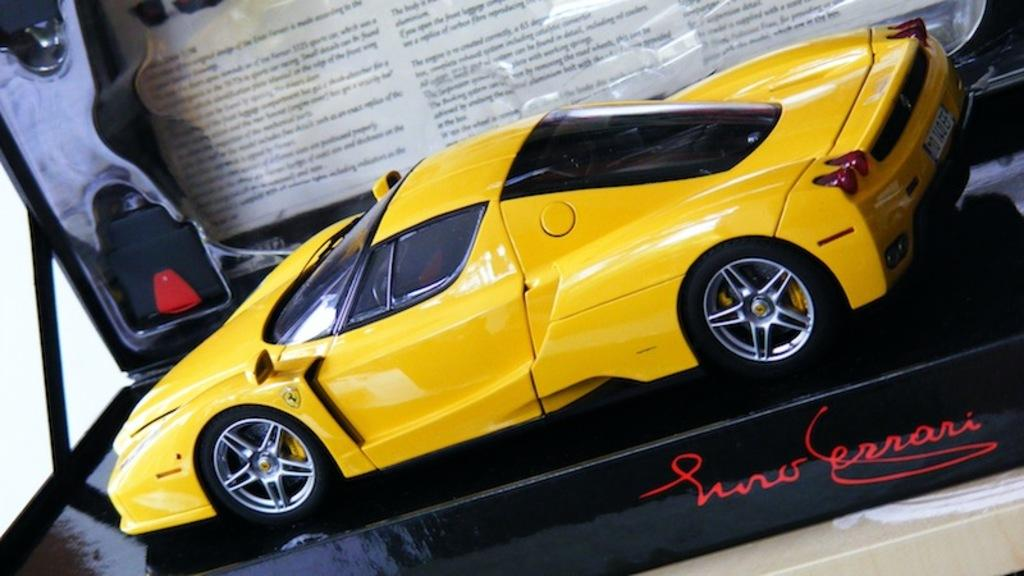What is the main object in the center of the image? There is a toy car in the center of the image. What else can be seen in the background of the image? There is a board visible in the background of the image. How many deer are present in the image? There are no deer present in the image; it features a toy car and a board. What type of cord is used to connect the toy car to the board? There is no cord connecting the toy car to the board in the image. 